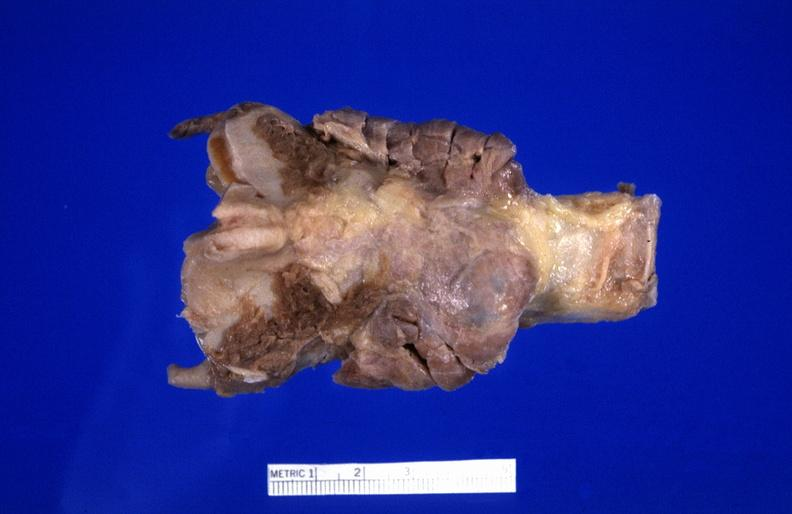does this image show hashimoto 's thyroiditis?
Answer the question using a single word or phrase. Yes 